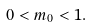<formula> <loc_0><loc_0><loc_500><loc_500>0 < m _ { 0 } < 1 .</formula> 